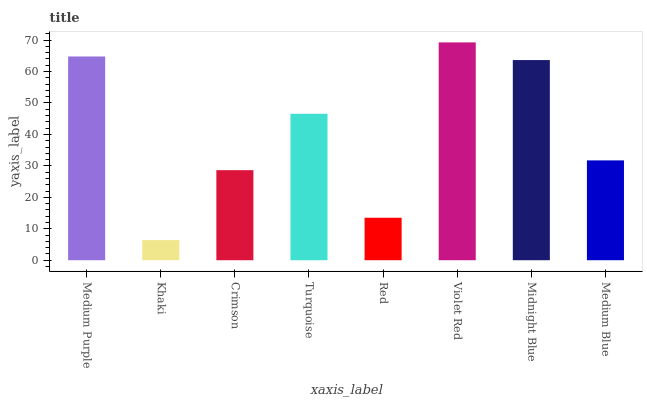Is Khaki the minimum?
Answer yes or no. Yes. Is Violet Red the maximum?
Answer yes or no. Yes. Is Crimson the minimum?
Answer yes or no. No. Is Crimson the maximum?
Answer yes or no. No. Is Crimson greater than Khaki?
Answer yes or no. Yes. Is Khaki less than Crimson?
Answer yes or no. Yes. Is Khaki greater than Crimson?
Answer yes or no. No. Is Crimson less than Khaki?
Answer yes or no. No. Is Turquoise the high median?
Answer yes or no. Yes. Is Medium Blue the low median?
Answer yes or no. Yes. Is Midnight Blue the high median?
Answer yes or no. No. Is Midnight Blue the low median?
Answer yes or no. No. 